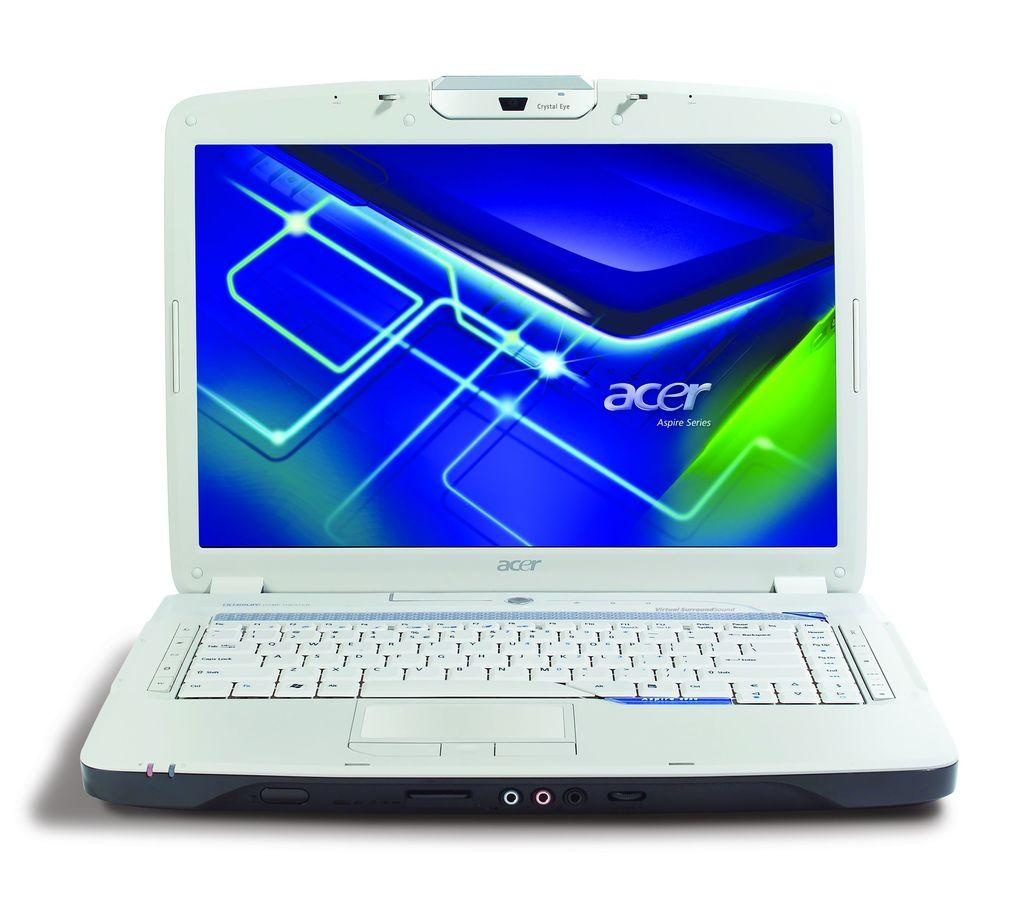<image>
Share a concise interpretation of the image provided. A white acer Aspire Series laptop with a blue screensaver on. 